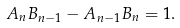<formula> <loc_0><loc_0><loc_500><loc_500>A _ { n } B _ { n - 1 } - A _ { n - 1 } B _ { n } = 1 .</formula> 